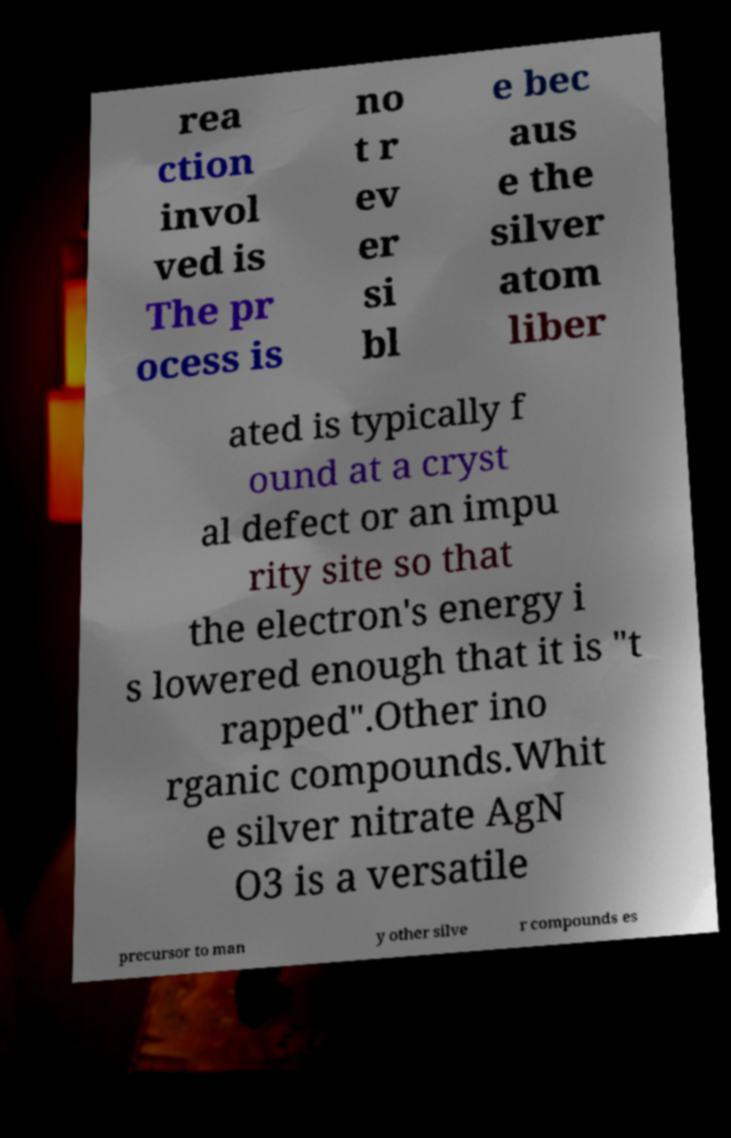What messages or text are displayed in this image? I need them in a readable, typed format. rea ction invol ved is The pr ocess is no t r ev er si bl e bec aus e the silver atom liber ated is typically f ound at a cryst al defect or an impu rity site so that the electron's energy i s lowered enough that it is "t rapped".Other ino rganic compounds.Whit e silver nitrate AgN O3 is a versatile precursor to man y other silve r compounds es 